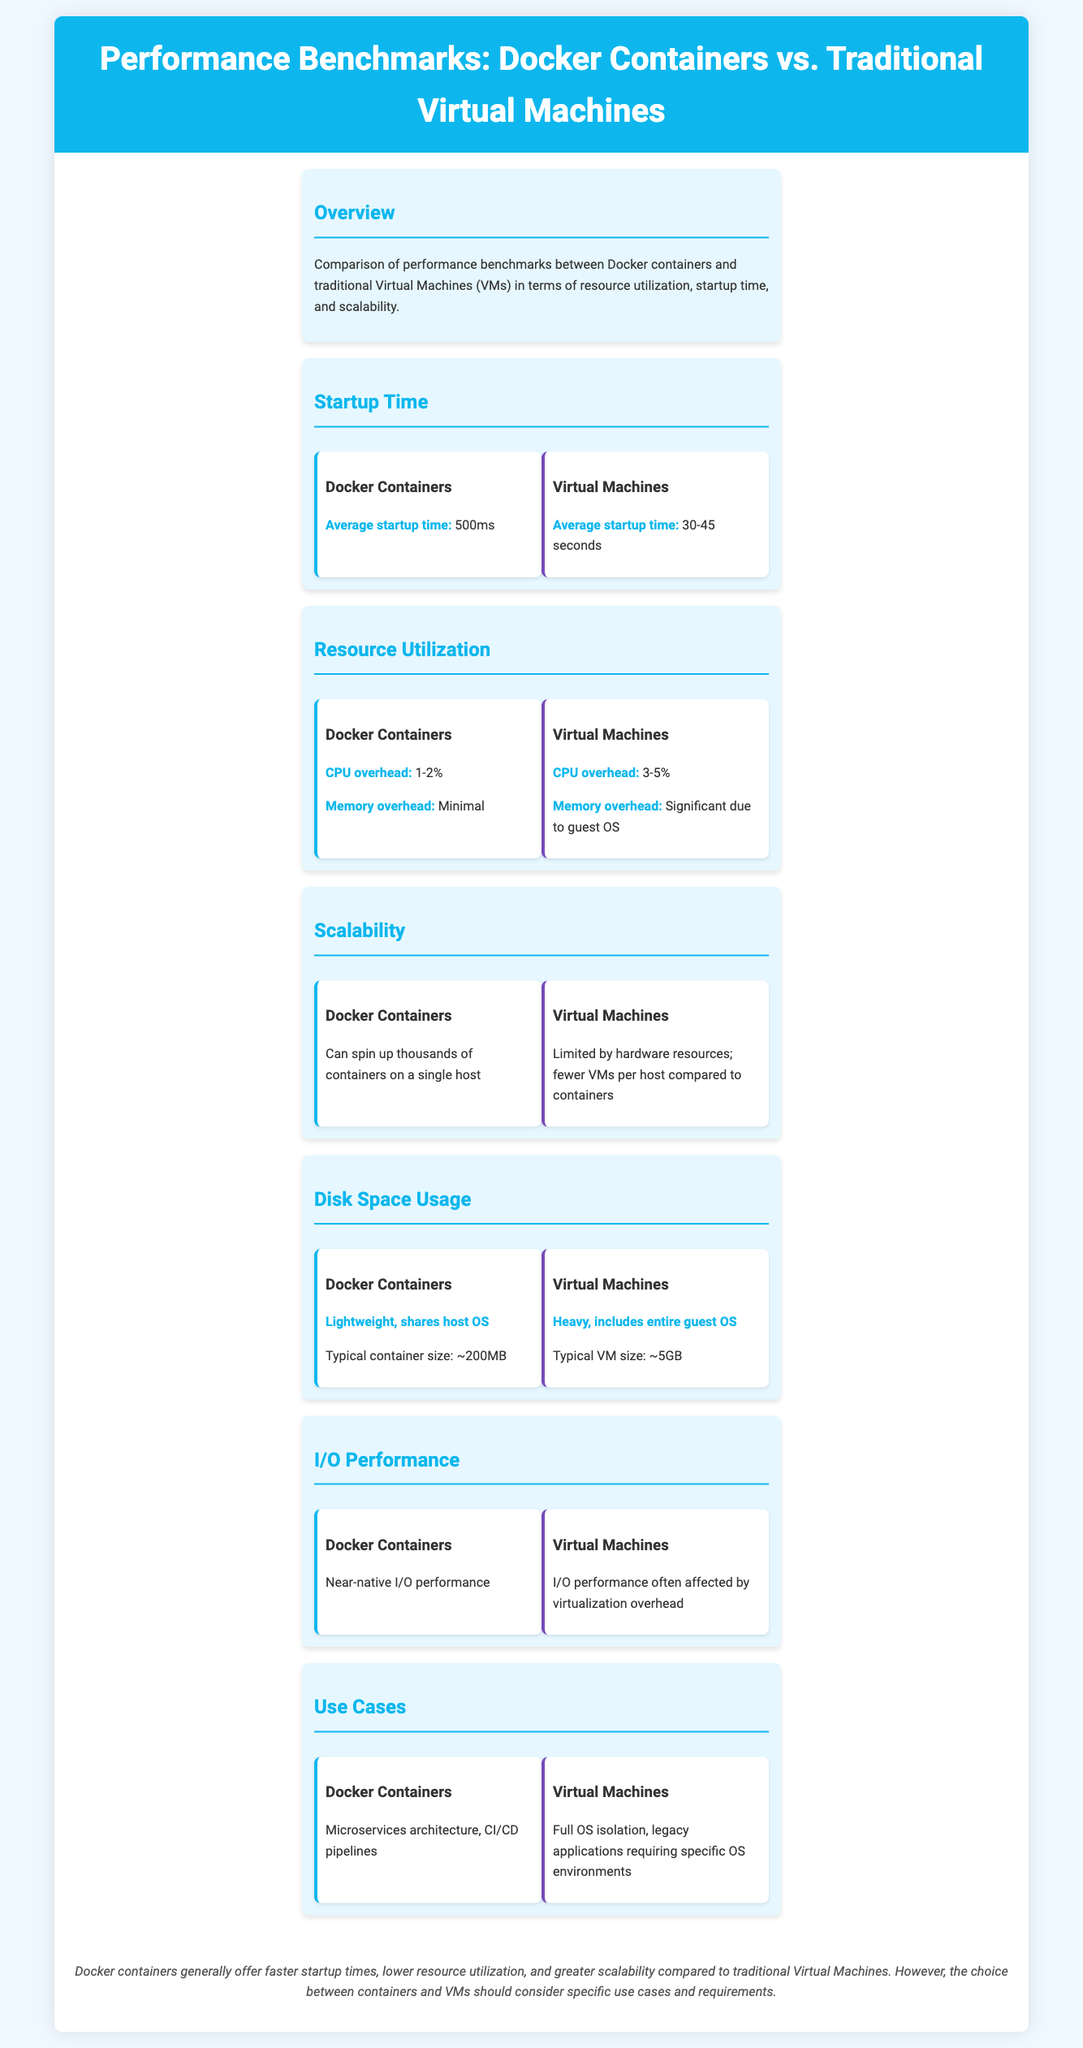What is the average startup time for Docker containers? The average startup time for Docker containers is mentioned as 500ms in the document.
Answer: 500ms What is the CPU overhead for Virtual Machines? The document states that the CPU overhead for Virtual Machines is 3-5%.
Answer: 3-5% How many containers can Docker spin up on a single host? The document notes that Docker can spin up thousands of containers on a single host.
Answer: Thousands What is the typical container size for Docker? The typical size of a Docker container is mentioned in the document as approximately 200MB.
Answer: ~200MB What is a key use case for Virtual Machines? The document lists full OS isolation as a key use case for Virtual Machines.
Answer: Full OS isolation What does Docker offer compared to traditional Virtual Machines in terms of resource utilization? The document highlights that Docker containers offer lower resource utilization compared to traditional Virtual Machines.
Answer: Lower resource utilization What impact does virtualization have on Virtual Machines' I/O performance? The document states that I/O performance for Virtual Machines is often affected by virtualization overhead.
Answer: Affected by virtualization overhead What is the average startup time range for Virtual Machines? The document specifies that the average startup time for Virtual Machines ranges from 30 to 45 seconds.
Answer: 30-45 seconds 